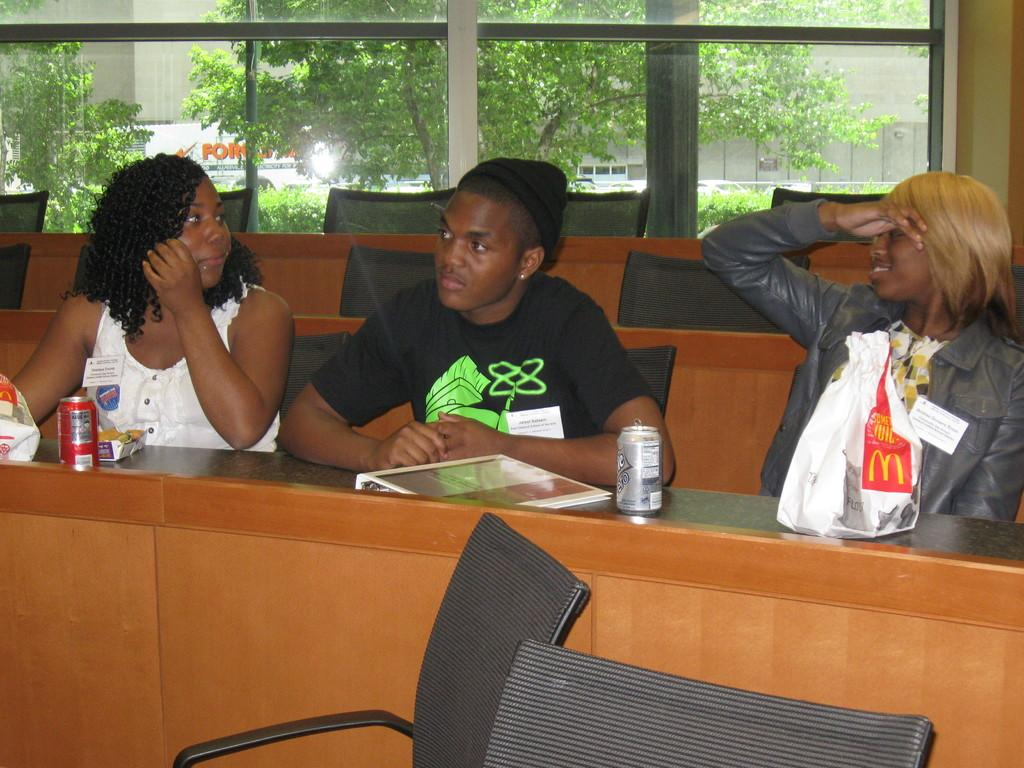How many people are present in the image? There are three people in the image. Can you describe the facial expression of one of the people? One of the people is smiling. What can be seen in the background of the image? There are trees and a window in the background of the image. What type of pet is sitting on the lap of the person in the image? There is no pet present in the image. How many hands does the person in the image have? The number of hands a person has cannot be determined from the image alone, as it is a common feature among humans. 